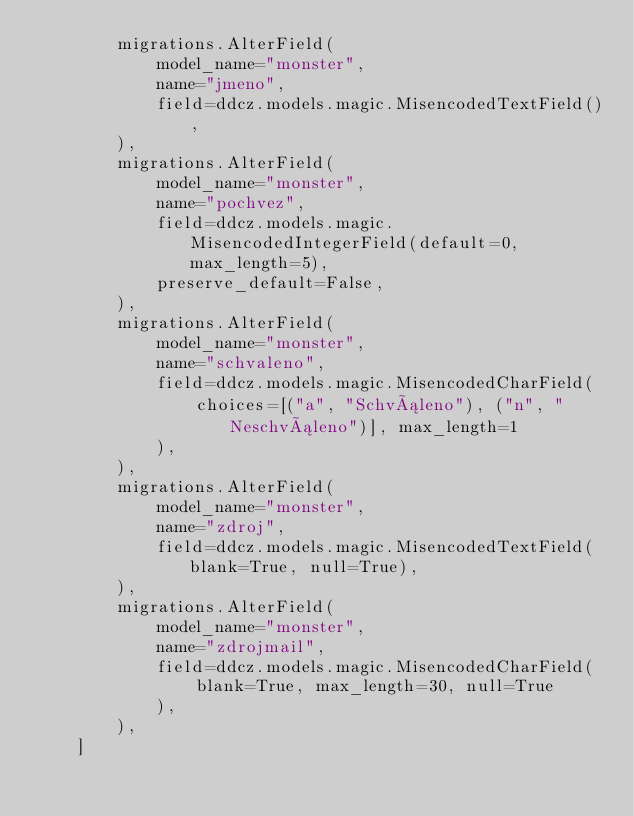<code> <loc_0><loc_0><loc_500><loc_500><_Python_>        migrations.AlterField(
            model_name="monster",
            name="jmeno",
            field=ddcz.models.magic.MisencodedTextField(),
        ),
        migrations.AlterField(
            model_name="monster",
            name="pochvez",
            field=ddcz.models.magic.MisencodedIntegerField(default=0, max_length=5),
            preserve_default=False,
        ),
        migrations.AlterField(
            model_name="monster",
            name="schvaleno",
            field=ddcz.models.magic.MisencodedCharField(
                choices=[("a", "Schváleno"), ("n", "Neschváleno")], max_length=1
            ),
        ),
        migrations.AlterField(
            model_name="monster",
            name="zdroj",
            field=ddcz.models.magic.MisencodedTextField(blank=True, null=True),
        ),
        migrations.AlterField(
            model_name="monster",
            name="zdrojmail",
            field=ddcz.models.magic.MisencodedCharField(
                blank=True, max_length=30, null=True
            ),
        ),
    ]
</code> 